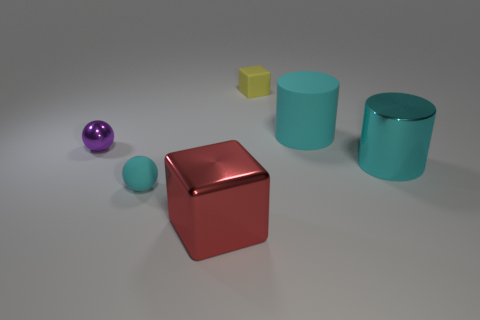Add 1 purple shiny cylinders. How many objects exist? 7 Subtract all cyan balls. How many balls are left? 1 Subtract all spheres. How many objects are left? 4 Subtract 1 spheres. How many spheres are left? 1 Subtract all cyan blocks. Subtract all yellow balls. How many blocks are left? 2 Subtract all green spheres. How many blue cylinders are left? 0 Subtract all tiny red metallic cubes. Subtract all big red blocks. How many objects are left? 5 Add 4 big red blocks. How many big red blocks are left? 5 Add 2 yellow rubber things. How many yellow rubber things exist? 3 Subtract 0 gray cubes. How many objects are left? 6 